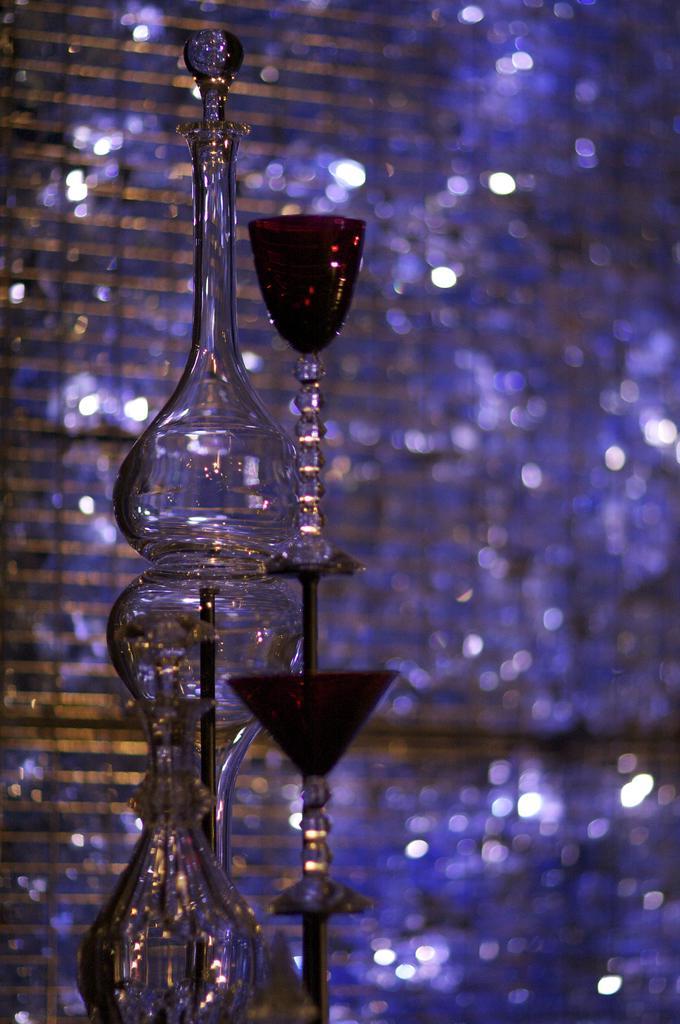How would you summarize this image in a sentence or two? There is a timer. Above the timer is the glass beaker. Next to the beaker is the glass. 